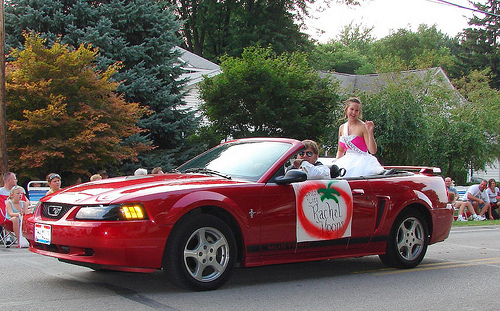<image>
Is the girl behind the car? No. The girl is not behind the car. From this viewpoint, the girl appears to be positioned elsewhere in the scene. Is the woman in the car? Yes. The woman is contained within or inside the car, showing a containment relationship. 